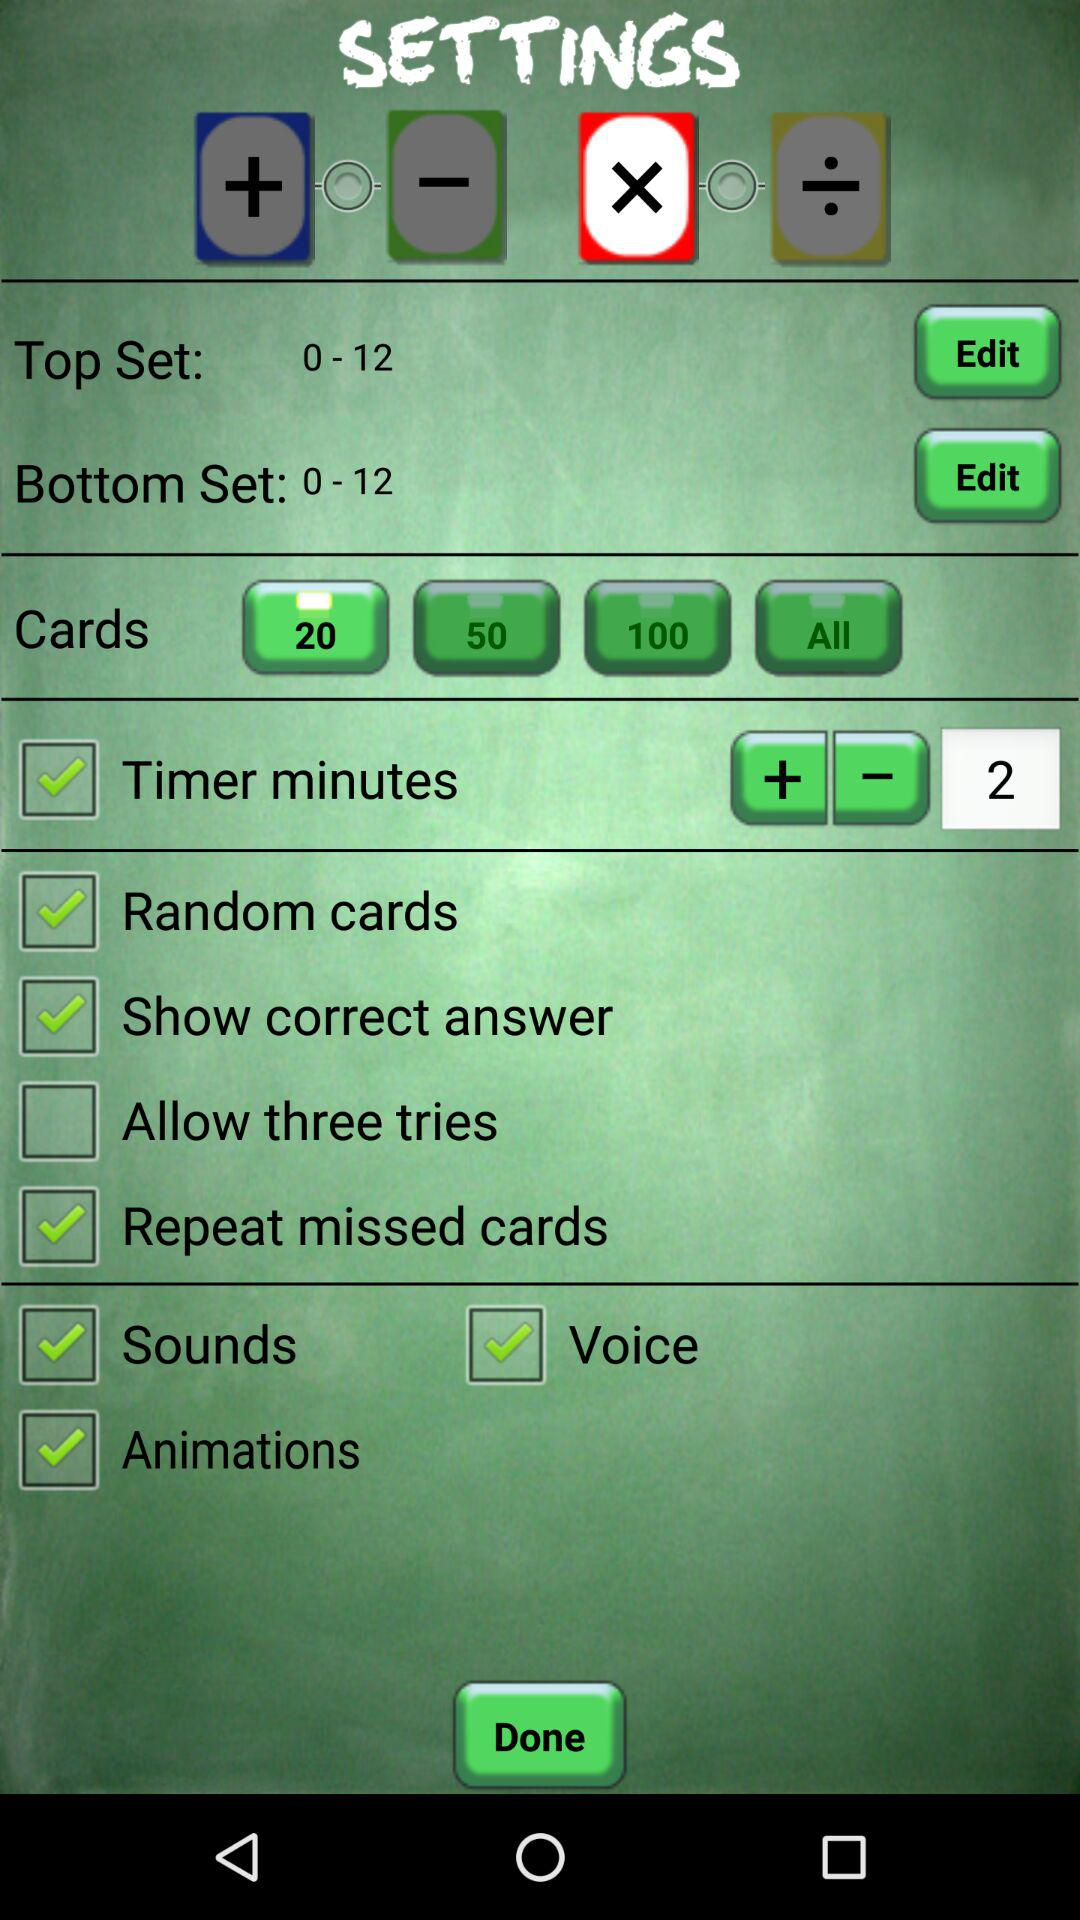What is the number of selected cards? The selected number is 20. 